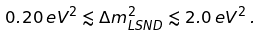<formula> <loc_0><loc_0><loc_500><loc_500>0 . 2 0 \, e V ^ { 2 } \lesssim \Delta { m } ^ { 2 } _ { L S N D } \lesssim 2 . 0 \, e V ^ { 2 } \, .</formula> 